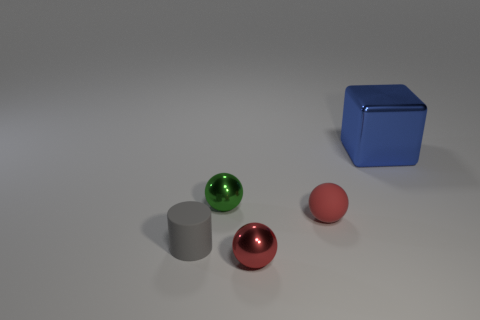Add 5 large red objects. How many objects exist? 10 Subtract all green balls. How many balls are left? 2 Subtract 0 cyan cylinders. How many objects are left? 5 Subtract all spheres. How many objects are left? 2 Subtract 1 cylinders. How many cylinders are left? 0 Subtract all yellow cylinders. Subtract all yellow blocks. How many cylinders are left? 1 Subtract all blue cylinders. How many red spheres are left? 2 Subtract all small red objects. Subtract all small gray matte cylinders. How many objects are left? 2 Add 5 red shiny spheres. How many red shiny spheres are left? 6 Add 5 metal spheres. How many metal spheres exist? 7 